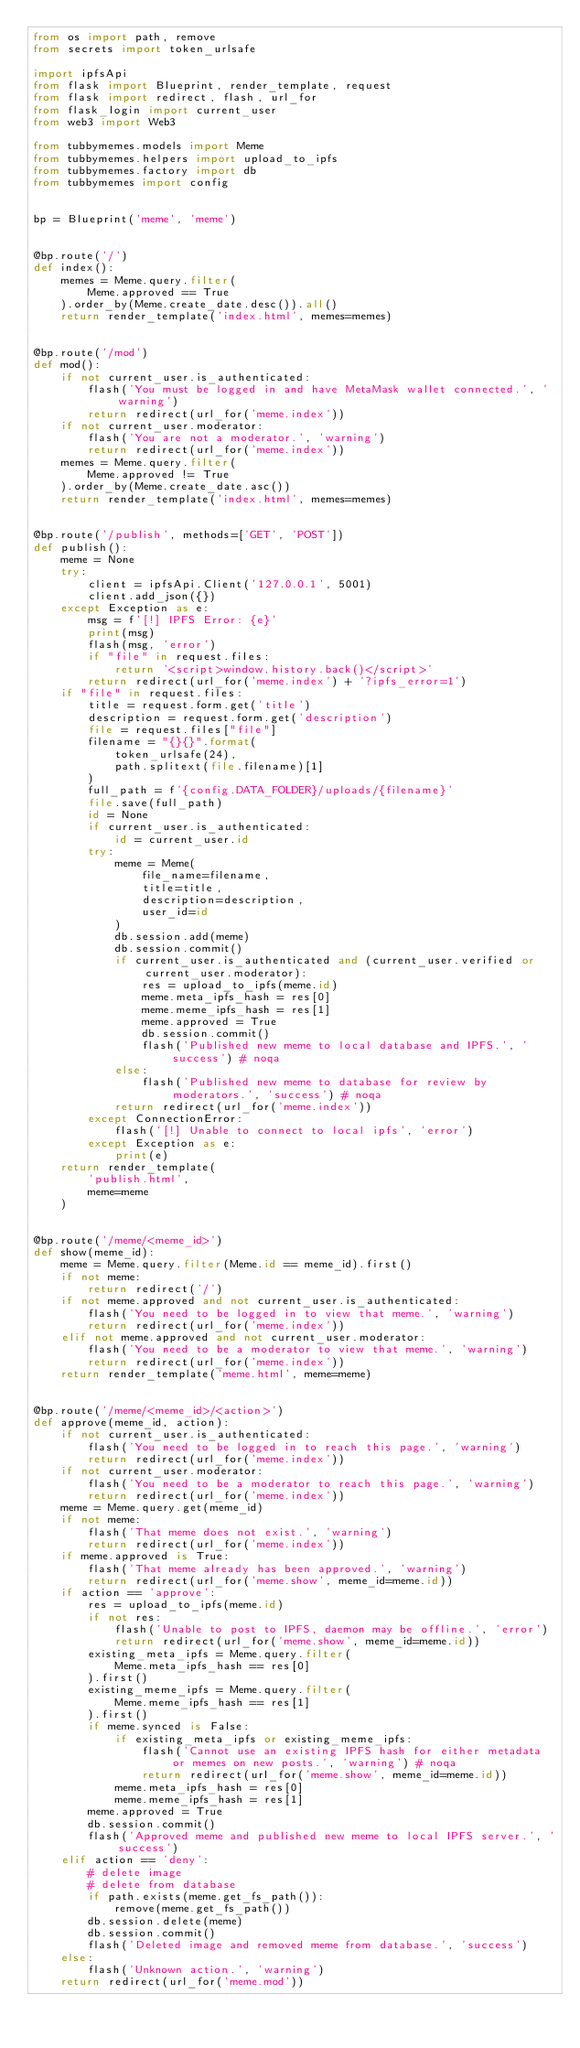Convert code to text. <code><loc_0><loc_0><loc_500><loc_500><_Python_>from os import path, remove
from secrets import token_urlsafe

import ipfsApi
from flask import Blueprint, render_template, request
from flask import redirect, flash, url_for
from flask_login import current_user
from web3 import Web3

from tubbymemes.models import Meme
from tubbymemes.helpers import upload_to_ipfs
from tubbymemes.factory import db
from tubbymemes import config


bp = Blueprint('meme', 'meme')


@bp.route('/')
def index():
    memes = Meme.query.filter(
        Meme.approved == True
    ).order_by(Meme.create_date.desc()).all()
    return render_template('index.html', memes=memes)


@bp.route('/mod')
def mod():
    if not current_user.is_authenticated:
        flash('You must be logged in and have MetaMask wallet connected.', 'warning')
        return redirect(url_for('meme.index'))
    if not current_user.moderator:
        flash('You are not a moderator.', 'warning')
        return redirect(url_for('meme.index'))
    memes = Meme.query.filter(
        Meme.approved != True
    ).order_by(Meme.create_date.asc())
    return render_template('index.html', memes=memes)


@bp.route('/publish', methods=['GET', 'POST'])
def publish():
    meme = None
    try:
        client = ipfsApi.Client('127.0.0.1', 5001)
        client.add_json({})
    except Exception as e:
        msg = f'[!] IPFS Error: {e}'
        print(msg)
        flash(msg, 'error')
        if "file" in request.files:
            return '<script>window.history.back()</script>'
        return redirect(url_for('meme.index') + '?ipfs_error=1')
    if "file" in request.files:
        title = request.form.get('title')
        description = request.form.get('description')
        file = request.files["file"]
        filename = "{}{}".format(
            token_urlsafe(24),
            path.splitext(file.filename)[1]
        )
        full_path = f'{config.DATA_FOLDER}/uploads/{filename}'
        file.save(full_path)
        id = None
        if current_user.is_authenticated:
            id = current_user.id
        try:
            meme = Meme(
                file_name=filename,
                title=title,
                description=description,
                user_id=id
            )
            db.session.add(meme)
            db.session.commit()
            if current_user.is_authenticated and (current_user.verified or current_user.moderator):
                res = upload_to_ipfs(meme.id)
                meme.meta_ipfs_hash = res[0]
                meme.meme_ipfs_hash = res[1]
                meme.approved = True
                db.session.commit()
                flash('Published new meme to local database and IPFS.', 'success') # noqa
            else:
                flash('Published new meme to database for review by moderators.', 'success') # noqa
            return redirect(url_for('meme.index'))
        except ConnectionError:
            flash('[!] Unable to connect to local ipfs', 'error')
        except Exception as e:
            print(e)
    return render_template(
        'publish.html',
        meme=meme
    )


@bp.route('/meme/<meme_id>')
def show(meme_id):
    meme = Meme.query.filter(Meme.id == meme_id).first()
    if not meme:
        return redirect('/')
    if not meme.approved and not current_user.is_authenticated:
        flash('You need to be logged in to view that meme.', 'warning')
        return redirect(url_for('meme.index'))
    elif not meme.approved and not current_user.moderator:
        flash('You need to be a moderator to view that meme.', 'warning')
        return redirect(url_for('meme.index'))
    return render_template('meme.html', meme=meme)


@bp.route('/meme/<meme_id>/<action>')
def approve(meme_id, action):
    if not current_user.is_authenticated:
        flash('You need to be logged in to reach this page.', 'warning')
        return redirect(url_for('meme.index'))
    if not current_user.moderator:
        flash('You need to be a moderator to reach this page.', 'warning')
        return redirect(url_for('meme.index'))
    meme = Meme.query.get(meme_id)
    if not meme:
        flash('That meme does not exist.', 'warning')
        return redirect(url_for('meme.index'))
    if meme.approved is True:
        flash('That meme already has been approved.', 'warning')
        return redirect(url_for('meme.show', meme_id=meme.id))
    if action == 'approve':
        res = upload_to_ipfs(meme.id)
        if not res:
            flash('Unable to post to IPFS, daemon may be offline.', 'error')
            return redirect(url_for('meme.show', meme_id=meme.id))
        existing_meta_ipfs = Meme.query.filter(
            Meme.meta_ipfs_hash == res[0]
        ).first()
        existing_meme_ipfs = Meme.query.filter(
            Meme.meme_ipfs_hash == res[1]
        ).first()
        if meme.synced is False:
            if existing_meta_ipfs or existing_meme_ipfs:
                flash('Cannot use an existing IPFS hash for either metadata or memes on new posts.', 'warning') # noqa
                return redirect(url_for('meme.show', meme_id=meme.id))
            meme.meta_ipfs_hash = res[0]
            meme.meme_ipfs_hash = res[1]
        meme.approved = True
        db.session.commit()
        flash('Approved meme and published new meme to local IPFS server.', 'success')
    elif action == 'deny':
        # delete image
        # delete from database
        if path.exists(meme.get_fs_path()):
            remove(meme.get_fs_path())
        db.session.delete(meme)
        db.session.commit()
        flash('Deleted image and removed meme from database.', 'success')
    else:
        flash('Unknown action.', 'warning')
    return redirect(url_for('meme.mod'))
</code> 